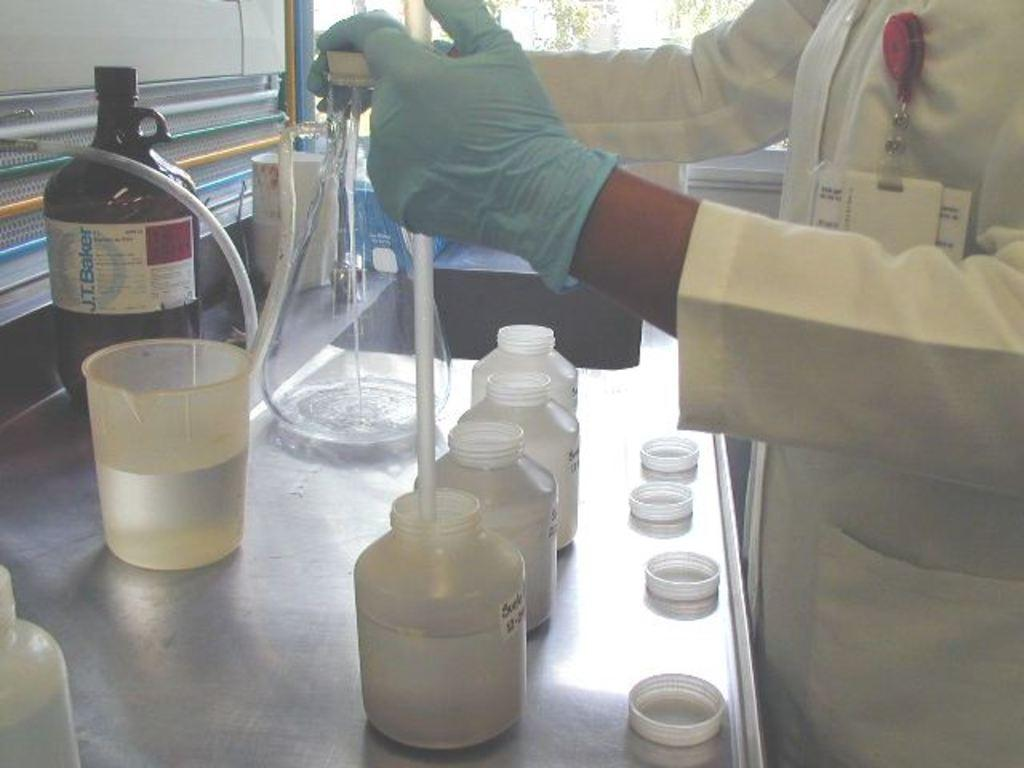Provide a one-sentence caption for the provided image. a scientist in a lab in front of jars and a bottle of J.T. Baker. 